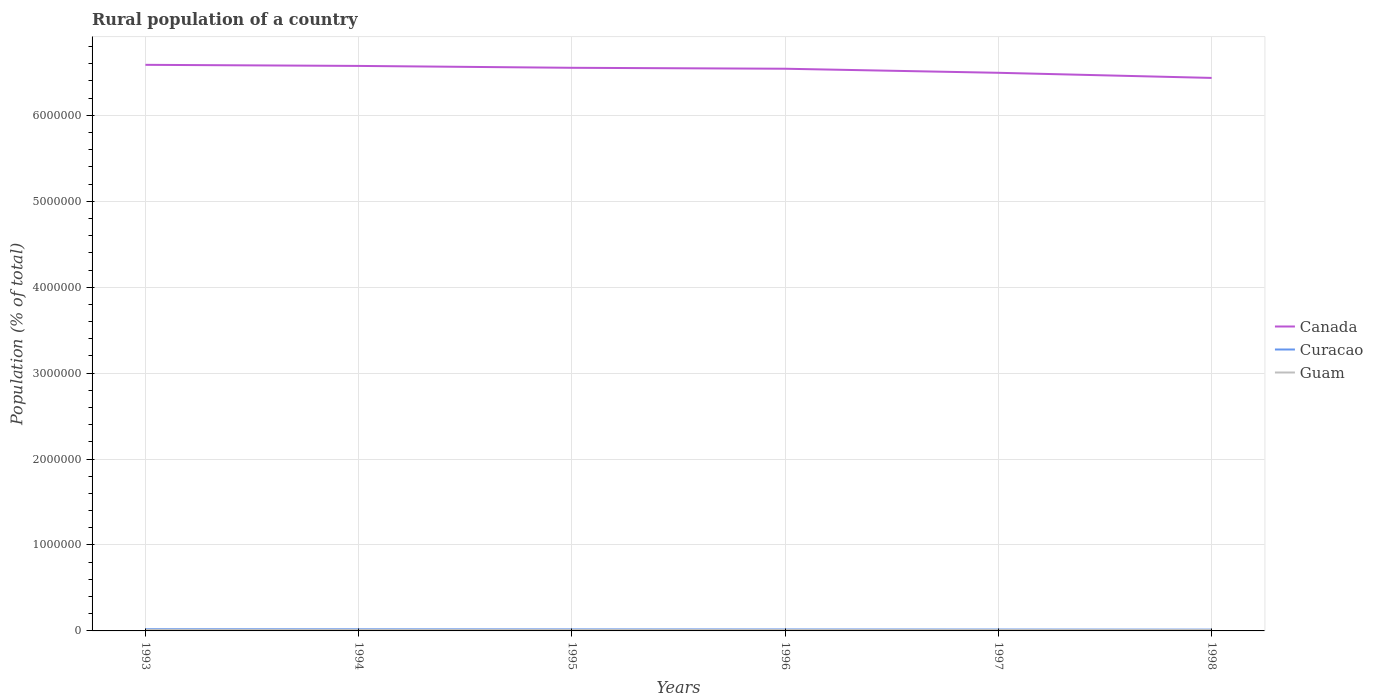Across all years, what is the maximum rural population in Curacao?
Make the answer very short. 1.50e+04. What is the total rural population in Curacao in the graph?
Make the answer very short. 2685. What is the difference between the highest and the second highest rural population in Guam?
Ensure brevity in your answer.  719. Is the rural population in Curacao strictly greater than the rural population in Canada over the years?
Make the answer very short. Yes. Does the graph contain any zero values?
Keep it short and to the point. No. How many legend labels are there?
Your answer should be very brief. 3. How are the legend labels stacked?
Offer a terse response. Vertical. What is the title of the graph?
Your response must be concise. Rural population of a country. What is the label or title of the Y-axis?
Give a very brief answer. Population (% of total). What is the Population (% of total) of Canada in 1993?
Your response must be concise. 6.59e+06. What is the Population (% of total) of Curacao in 1993?
Give a very brief answer. 1.99e+04. What is the Population (% of total) of Guam in 1993?
Your answer should be very brief. 1.18e+04. What is the Population (% of total) of Canada in 1994?
Your answer should be compact. 6.58e+06. What is the Population (% of total) in Curacao in 1994?
Give a very brief answer. 1.88e+04. What is the Population (% of total) of Guam in 1994?
Keep it short and to the point. 1.17e+04. What is the Population (% of total) of Canada in 1995?
Keep it short and to the point. 6.55e+06. What is the Population (% of total) in Curacao in 1995?
Give a very brief answer. 1.79e+04. What is the Population (% of total) in Guam in 1995?
Your answer should be very brief. 1.16e+04. What is the Population (% of total) in Canada in 1996?
Give a very brief answer. 6.54e+06. What is the Population (% of total) in Curacao in 1996?
Your answer should be very brief. 1.70e+04. What is the Population (% of total) in Guam in 1996?
Keep it short and to the point. 1.14e+04. What is the Population (% of total) of Canada in 1997?
Keep it short and to the point. 6.50e+06. What is the Population (% of total) of Curacao in 1997?
Offer a terse response. 1.62e+04. What is the Population (% of total) of Guam in 1997?
Provide a succinct answer. 1.13e+04. What is the Population (% of total) in Canada in 1998?
Offer a very short reply. 6.44e+06. What is the Population (% of total) of Curacao in 1998?
Make the answer very short. 1.50e+04. What is the Population (% of total) of Guam in 1998?
Your answer should be very brief. 1.11e+04. Across all years, what is the maximum Population (% of total) in Canada?
Your answer should be very brief. 6.59e+06. Across all years, what is the maximum Population (% of total) of Curacao?
Provide a short and direct response. 1.99e+04. Across all years, what is the maximum Population (% of total) of Guam?
Make the answer very short. 1.18e+04. Across all years, what is the minimum Population (% of total) of Canada?
Offer a terse response. 6.44e+06. Across all years, what is the minimum Population (% of total) of Curacao?
Offer a very short reply. 1.50e+04. Across all years, what is the minimum Population (% of total) of Guam?
Offer a very short reply. 1.11e+04. What is the total Population (% of total) of Canada in the graph?
Provide a succinct answer. 3.92e+07. What is the total Population (% of total) of Curacao in the graph?
Keep it short and to the point. 1.05e+05. What is the total Population (% of total) in Guam in the graph?
Your response must be concise. 6.88e+04. What is the difference between the Population (% of total) in Canada in 1993 and that in 1994?
Offer a very short reply. 1.26e+04. What is the difference between the Population (% of total) of Curacao in 1993 and that in 1994?
Ensure brevity in your answer.  1032. What is the difference between the Population (% of total) of Guam in 1993 and that in 1994?
Provide a short and direct response. 98. What is the difference between the Population (% of total) in Canada in 1993 and that in 1995?
Keep it short and to the point. 3.46e+04. What is the difference between the Population (% of total) of Curacao in 1993 and that in 1995?
Offer a terse response. 1998. What is the difference between the Population (% of total) in Guam in 1993 and that in 1995?
Ensure brevity in your answer.  220. What is the difference between the Population (% of total) of Canada in 1993 and that in 1996?
Provide a short and direct response. 4.55e+04. What is the difference between the Population (% of total) of Curacao in 1993 and that in 1996?
Give a very brief answer. 2846. What is the difference between the Population (% of total) in Guam in 1993 and that in 1996?
Provide a succinct answer. 365. What is the difference between the Population (% of total) in Canada in 1993 and that in 1997?
Offer a very short reply. 9.26e+04. What is the difference between the Population (% of total) in Curacao in 1993 and that in 1997?
Give a very brief answer. 3717. What is the difference between the Population (% of total) of Guam in 1993 and that in 1997?
Offer a terse response. 532. What is the difference between the Population (% of total) in Canada in 1993 and that in 1998?
Your answer should be compact. 1.52e+05. What is the difference between the Population (% of total) of Curacao in 1993 and that in 1998?
Offer a very short reply. 4876. What is the difference between the Population (% of total) in Guam in 1993 and that in 1998?
Ensure brevity in your answer.  719. What is the difference between the Population (% of total) of Canada in 1994 and that in 1995?
Keep it short and to the point. 2.19e+04. What is the difference between the Population (% of total) of Curacao in 1994 and that in 1995?
Offer a very short reply. 966. What is the difference between the Population (% of total) of Guam in 1994 and that in 1995?
Ensure brevity in your answer.  122. What is the difference between the Population (% of total) in Canada in 1994 and that in 1996?
Your response must be concise. 3.29e+04. What is the difference between the Population (% of total) in Curacao in 1994 and that in 1996?
Provide a succinct answer. 1814. What is the difference between the Population (% of total) of Guam in 1994 and that in 1996?
Your answer should be very brief. 267. What is the difference between the Population (% of total) of Canada in 1994 and that in 1997?
Offer a very short reply. 8.00e+04. What is the difference between the Population (% of total) in Curacao in 1994 and that in 1997?
Offer a terse response. 2685. What is the difference between the Population (% of total) in Guam in 1994 and that in 1997?
Make the answer very short. 434. What is the difference between the Population (% of total) in Canada in 1994 and that in 1998?
Offer a very short reply. 1.40e+05. What is the difference between the Population (% of total) of Curacao in 1994 and that in 1998?
Your answer should be very brief. 3844. What is the difference between the Population (% of total) in Guam in 1994 and that in 1998?
Keep it short and to the point. 621. What is the difference between the Population (% of total) of Canada in 1995 and that in 1996?
Ensure brevity in your answer.  1.09e+04. What is the difference between the Population (% of total) in Curacao in 1995 and that in 1996?
Keep it short and to the point. 848. What is the difference between the Population (% of total) in Guam in 1995 and that in 1996?
Your answer should be very brief. 145. What is the difference between the Population (% of total) of Canada in 1995 and that in 1997?
Your answer should be very brief. 5.81e+04. What is the difference between the Population (% of total) of Curacao in 1995 and that in 1997?
Offer a very short reply. 1719. What is the difference between the Population (% of total) of Guam in 1995 and that in 1997?
Your response must be concise. 312. What is the difference between the Population (% of total) in Canada in 1995 and that in 1998?
Provide a short and direct response. 1.18e+05. What is the difference between the Population (% of total) in Curacao in 1995 and that in 1998?
Your response must be concise. 2878. What is the difference between the Population (% of total) in Guam in 1995 and that in 1998?
Provide a short and direct response. 499. What is the difference between the Population (% of total) in Canada in 1996 and that in 1997?
Keep it short and to the point. 4.71e+04. What is the difference between the Population (% of total) in Curacao in 1996 and that in 1997?
Your response must be concise. 871. What is the difference between the Population (% of total) of Guam in 1996 and that in 1997?
Offer a very short reply. 167. What is the difference between the Population (% of total) of Canada in 1996 and that in 1998?
Keep it short and to the point. 1.07e+05. What is the difference between the Population (% of total) in Curacao in 1996 and that in 1998?
Your answer should be compact. 2030. What is the difference between the Population (% of total) in Guam in 1996 and that in 1998?
Your answer should be compact. 354. What is the difference between the Population (% of total) in Canada in 1997 and that in 1998?
Keep it short and to the point. 5.97e+04. What is the difference between the Population (% of total) in Curacao in 1997 and that in 1998?
Your answer should be compact. 1159. What is the difference between the Population (% of total) of Guam in 1997 and that in 1998?
Keep it short and to the point. 187. What is the difference between the Population (% of total) in Canada in 1993 and the Population (% of total) in Curacao in 1994?
Keep it short and to the point. 6.57e+06. What is the difference between the Population (% of total) of Canada in 1993 and the Population (% of total) of Guam in 1994?
Make the answer very short. 6.58e+06. What is the difference between the Population (% of total) of Curacao in 1993 and the Population (% of total) of Guam in 1994?
Offer a very short reply. 8192. What is the difference between the Population (% of total) of Canada in 1993 and the Population (% of total) of Curacao in 1995?
Your answer should be compact. 6.57e+06. What is the difference between the Population (% of total) of Canada in 1993 and the Population (% of total) of Guam in 1995?
Your response must be concise. 6.58e+06. What is the difference between the Population (% of total) of Curacao in 1993 and the Population (% of total) of Guam in 1995?
Provide a short and direct response. 8314. What is the difference between the Population (% of total) of Canada in 1993 and the Population (% of total) of Curacao in 1996?
Make the answer very short. 6.57e+06. What is the difference between the Population (% of total) of Canada in 1993 and the Population (% of total) of Guam in 1996?
Ensure brevity in your answer.  6.58e+06. What is the difference between the Population (% of total) of Curacao in 1993 and the Population (% of total) of Guam in 1996?
Your response must be concise. 8459. What is the difference between the Population (% of total) of Canada in 1993 and the Population (% of total) of Curacao in 1997?
Keep it short and to the point. 6.57e+06. What is the difference between the Population (% of total) of Canada in 1993 and the Population (% of total) of Guam in 1997?
Make the answer very short. 6.58e+06. What is the difference between the Population (% of total) in Curacao in 1993 and the Population (% of total) in Guam in 1997?
Make the answer very short. 8626. What is the difference between the Population (% of total) of Canada in 1993 and the Population (% of total) of Curacao in 1998?
Offer a very short reply. 6.57e+06. What is the difference between the Population (% of total) in Canada in 1993 and the Population (% of total) in Guam in 1998?
Give a very brief answer. 6.58e+06. What is the difference between the Population (% of total) in Curacao in 1993 and the Population (% of total) in Guam in 1998?
Make the answer very short. 8813. What is the difference between the Population (% of total) in Canada in 1994 and the Population (% of total) in Curacao in 1995?
Provide a succinct answer. 6.56e+06. What is the difference between the Population (% of total) in Canada in 1994 and the Population (% of total) in Guam in 1995?
Give a very brief answer. 6.56e+06. What is the difference between the Population (% of total) in Curacao in 1994 and the Population (% of total) in Guam in 1995?
Make the answer very short. 7282. What is the difference between the Population (% of total) of Canada in 1994 and the Population (% of total) of Curacao in 1996?
Offer a very short reply. 6.56e+06. What is the difference between the Population (% of total) in Canada in 1994 and the Population (% of total) in Guam in 1996?
Your answer should be compact. 6.56e+06. What is the difference between the Population (% of total) of Curacao in 1994 and the Population (% of total) of Guam in 1996?
Your response must be concise. 7427. What is the difference between the Population (% of total) of Canada in 1994 and the Population (% of total) of Curacao in 1997?
Give a very brief answer. 6.56e+06. What is the difference between the Population (% of total) of Canada in 1994 and the Population (% of total) of Guam in 1997?
Ensure brevity in your answer.  6.56e+06. What is the difference between the Population (% of total) in Curacao in 1994 and the Population (% of total) in Guam in 1997?
Your answer should be compact. 7594. What is the difference between the Population (% of total) of Canada in 1994 and the Population (% of total) of Curacao in 1998?
Your answer should be very brief. 6.56e+06. What is the difference between the Population (% of total) of Canada in 1994 and the Population (% of total) of Guam in 1998?
Your answer should be very brief. 6.56e+06. What is the difference between the Population (% of total) in Curacao in 1994 and the Population (% of total) in Guam in 1998?
Your response must be concise. 7781. What is the difference between the Population (% of total) in Canada in 1995 and the Population (% of total) in Curacao in 1996?
Your answer should be compact. 6.54e+06. What is the difference between the Population (% of total) of Canada in 1995 and the Population (% of total) of Guam in 1996?
Your answer should be compact. 6.54e+06. What is the difference between the Population (% of total) in Curacao in 1995 and the Population (% of total) in Guam in 1996?
Provide a short and direct response. 6461. What is the difference between the Population (% of total) of Canada in 1995 and the Population (% of total) of Curacao in 1997?
Offer a terse response. 6.54e+06. What is the difference between the Population (% of total) in Canada in 1995 and the Population (% of total) in Guam in 1997?
Your answer should be very brief. 6.54e+06. What is the difference between the Population (% of total) of Curacao in 1995 and the Population (% of total) of Guam in 1997?
Provide a short and direct response. 6628. What is the difference between the Population (% of total) of Canada in 1995 and the Population (% of total) of Curacao in 1998?
Your response must be concise. 6.54e+06. What is the difference between the Population (% of total) in Canada in 1995 and the Population (% of total) in Guam in 1998?
Keep it short and to the point. 6.54e+06. What is the difference between the Population (% of total) in Curacao in 1995 and the Population (% of total) in Guam in 1998?
Offer a terse response. 6815. What is the difference between the Population (% of total) of Canada in 1996 and the Population (% of total) of Curacao in 1997?
Your response must be concise. 6.53e+06. What is the difference between the Population (% of total) in Canada in 1996 and the Population (% of total) in Guam in 1997?
Give a very brief answer. 6.53e+06. What is the difference between the Population (% of total) in Curacao in 1996 and the Population (% of total) in Guam in 1997?
Offer a terse response. 5780. What is the difference between the Population (% of total) of Canada in 1996 and the Population (% of total) of Curacao in 1998?
Keep it short and to the point. 6.53e+06. What is the difference between the Population (% of total) of Canada in 1996 and the Population (% of total) of Guam in 1998?
Provide a short and direct response. 6.53e+06. What is the difference between the Population (% of total) of Curacao in 1996 and the Population (% of total) of Guam in 1998?
Your answer should be very brief. 5967. What is the difference between the Population (% of total) in Canada in 1997 and the Population (% of total) in Curacao in 1998?
Provide a short and direct response. 6.48e+06. What is the difference between the Population (% of total) in Canada in 1997 and the Population (% of total) in Guam in 1998?
Your answer should be compact. 6.48e+06. What is the difference between the Population (% of total) in Curacao in 1997 and the Population (% of total) in Guam in 1998?
Offer a terse response. 5096. What is the average Population (% of total) of Canada per year?
Provide a succinct answer. 6.53e+06. What is the average Population (% of total) in Curacao per year?
Offer a terse response. 1.75e+04. What is the average Population (% of total) of Guam per year?
Keep it short and to the point. 1.15e+04. In the year 1993, what is the difference between the Population (% of total) of Canada and Population (% of total) of Curacao?
Keep it short and to the point. 6.57e+06. In the year 1993, what is the difference between the Population (% of total) in Canada and Population (% of total) in Guam?
Provide a succinct answer. 6.58e+06. In the year 1993, what is the difference between the Population (% of total) of Curacao and Population (% of total) of Guam?
Provide a short and direct response. 8094. In the year 1994, what is the difference between the Population (% of total) in Canada and Population (% of total) in Curacao?
Provide a short and direct response. 6.56e+06. In the year 1994, what is the difference between the Population (% of total) in Canada and Population (% of total) in Guam?
Provide a succinct answer. 6.56e+06. In the year 1994, what is the difference between the Population (% of total) in Curacao and Population (% of total) in Guam?
Give a very brief answer. 7160. In the year 1995, what is the difference between the Population (% of total) in Canada and Population (% of total) in Curacao?
Provide a succinct answer. 6.54e+06. In the year 1995, what is the difference between the Population (% of total) of Canada and Population (% of total) of Guam?
Make the answer very short. 6.54e+06. In the year 1995, what is the difference between the Population (% of total) of Curacao and Population (% of total) of Guam?
Your response must be concise. 6316. In the year 1996, what is the difference between the Population (% of total) of Canada and Population (% of total) of Curacao?
Make the answer very short. 6.53e+06. In the year 1996, what is the difference between the Population (% of total) in Canada and Population (% of total) in Guam?
Your answer should be compact. 6.53e+06. In the year 1996, what is the difference between the Population (% of total) in Curacao and Population (% of total) in Guam?
Provide a succinct answer. 5613. In the year 1997, what is the difference between the Population (% of total) in Canada and Population (% of total) in Curacao?
Provide a succinct answer. 6.48e+06. In the year 1997, what is the difference between the Population (% of total) of Canada and Population (% of total) of Guam?
Provide a short and direct response. 6.48e+06. In the year 1997, what is the difference between the Population (% of total) of Curacao and Population (% of total) of Guam?
Keep it short and to the point. 4909. In the year 1998, what is the difference between the Population (% of total) in Canada and Population (% of total) in Curacao?
Offer a very short reply. 6.42e+06. In the year 1998, what is the difference between the Population (% of total) of Canada and Population (% of total) of Guam?
Your answer should be compact. 6.42e+06. In the year 1998, what is the difference between the Population (% of total) of Curacao and Population (% of total) of Guam?
Provide a succinct answer. 3937. What is the ratio of the Population (% of total) in Canada in 1993 to that in 1994?
Your answer should be very brief. 1. What is the ratio of the Population (% of total) in Curacao in 1993 to that in 1994?
Keep it short and to the point. 1.05. What is the ratio of the Population (% of total) of Guam in 1993 to that in 1994?
Ensure brevity in your answer.  1.01. What is the ratio of the Population (% of total) of Curacao in 1993 to that in 1995?
Keep it short and to the point. 1.11. What is the ratio of the Population (% of total) of Canada in 1993 to that in 1996?
Make the answer very short. 1.01. What is the ratio of the Population (% of total) in Curacao in 1993 to that in 1996?
Keep it short and to the point. 1.17. What is the ratio of the Population (% of total) in Guam in 1993 to that in 1996?
Provide a succinct answer. 1.03. What is the ratio of the Population (% of total) of Canada in 1993 to that in 1997?
Offer a terse response. 1.01. What is the ratio of the Population (% of total) of Curacao in 1993 to that in 1997?
Your response must be concise. 1.23. What is the ratio of the Population (% of total) of Guam in 1993 to that in 1997?
Your answer should be very brief. 1.05. What is the ratio of the Population (% of total) in Canada in 1993 to that in 1998?
Offer a terse response. 1.02. What is the ratio of the Population (% of total) of Curacao in 1993 to that in 1998?
Your answer should be compact. 1.32. What is the ratio of the Population (% of total) in Guam in 1993 to that in 1998?
Ensure brevity in your answer.  1.06. What is the ratio of the Population (% of total) of Canada in 1994 to that in 1995?
Your answer should be very brief. 1. What is the ratio of the Population (% of total) in Curacao in 1994 to that in 1995?
Give a very brief answer. 1.05. What is the ratio of the Population (% of total) of Guam in 1994 to that in 1995?
Provide a short and direct response. 1.01. What is the ratio of the Population (% of total) in Curacao in 1994 to that in 1996?
Your answer should be very brief. 1.11. What is the ratio of the Population (% of total) in Guam in 1994 to that in 1996?
Keep it short and to the point. 1.02. What is the ratio of the Population (% of total) of Canada in 1994 to that in 1997?
Make the answer very short. 1.01. What is the ratio of the Population (% of total) in Curacao in 1994 to that in 1997?
Offer a terse response. 1.17. What is the ratio of the Population (% of total) in Guam in 1994 to that in 1997?
Offer a terse response. 1.04. What is the ratio of the Population (% of total) in Canada in 1994 to that in 1998?
Offer a terse response. 1.02. What is the ratio of the Population (% of total) in Curacao in 1994 to that in 1998?
Offer a terse response. 1.26. What is the ratio of the Population (% of total) of Guam in 1994 to that in 1998?
Give a very brief answer. 1.06. What is the ratio of the Population (% of total) of Canada in 1995 to that in 1996?
Provide a succinct answer. 1. What is the ratio of the Population (% of total) in Curacao in 1995 to that in 1996?
Provide a short and direct response. 1.05. What is the ratio of the Population (% of total) of Guam in 1995 to that in 1996?
Offer a terse response. 1.01. What is the ratio of the Population (% of total) of Canada in 1995 to that in 1997?
Give a very brief answer. 1.01. What is the ratio of the Population (% of total) of Curacao in 1995 to that in 1997?
Your answer should be very brief. 1.11. What is the ratio of the Population (% of total) of Guam in 1995 to that in 1997?
Your answer should be compact. 1.03. What is the ratio of the Population (% of total) in Canada in 1995 to that in 1998?
Keep it short and to the point. 1.02. What is the ratio of the Population (% of total) of Curacao in 1995 to that in 1998?
Make the answer very short. 1.19. What is the ratio of the Population (% of total) of Guam in 1995 to that in 1998?
Your answer should be very brief. 1.05. What is the ratio of the Population (% of total) in Canada in 1996 to that in 1997?
Your answer should be compact. 1.01. What is the ratio of the Population (% of total) in Curacao in 1996 to that in 1997?
Offer a very short reply. 1.05. What is the ratio of the Population (% of total) of Guam in 1996 to that in 1997?
Ensure brevity in your answer.  1.01. What is the ratio of the Population (% of total) of Canada in 1996 to that in 1998?
Give a very brief answer. 1.02. What is the ratio of the Population (% of total) in Curacao in 1996 to that in 1998?
Keep it short and to the point. 1.14. What is the ratio of the Population (% of total) of Guam in 1996 to that in 1998?
Offer a terse response. 1.03. What is the ratio of the Population (% of total) of Canada in 1997 to that in 1998?
Offer a terse response. 1.01. What is the ratio of the Population (% of total) in Curacao in 1997 to that in 1998?
Provide a short and direct response. 1.08. What is the ratio of the Population (% of total) of Guam in 1997 to that in 1998?
Keep it short and to the point. 1.02. What is the difference between the highest and the second highest Population (% of total) of Canada?
Give a very brief answer. 1.26e+04. What is the difference between the highest and the second highest Population (% of total) of Curacao?
Your answer should be compact. 1032. What is the difference between the highest and the second highest Population (% of total) of Guam?
Provide a short and direct response. 98. What is the difference between the highest and the lowest Population (% of total) in Canada?
Offer a terse response. 1.52e+05. What is the difference between the highest and the lowest Population (% of total) in Curacao?
Your response must be concise. 4876. What is the difference between the highest and the lowest Population (% of total) in Guam?
Provide a succinct answer. 719. 